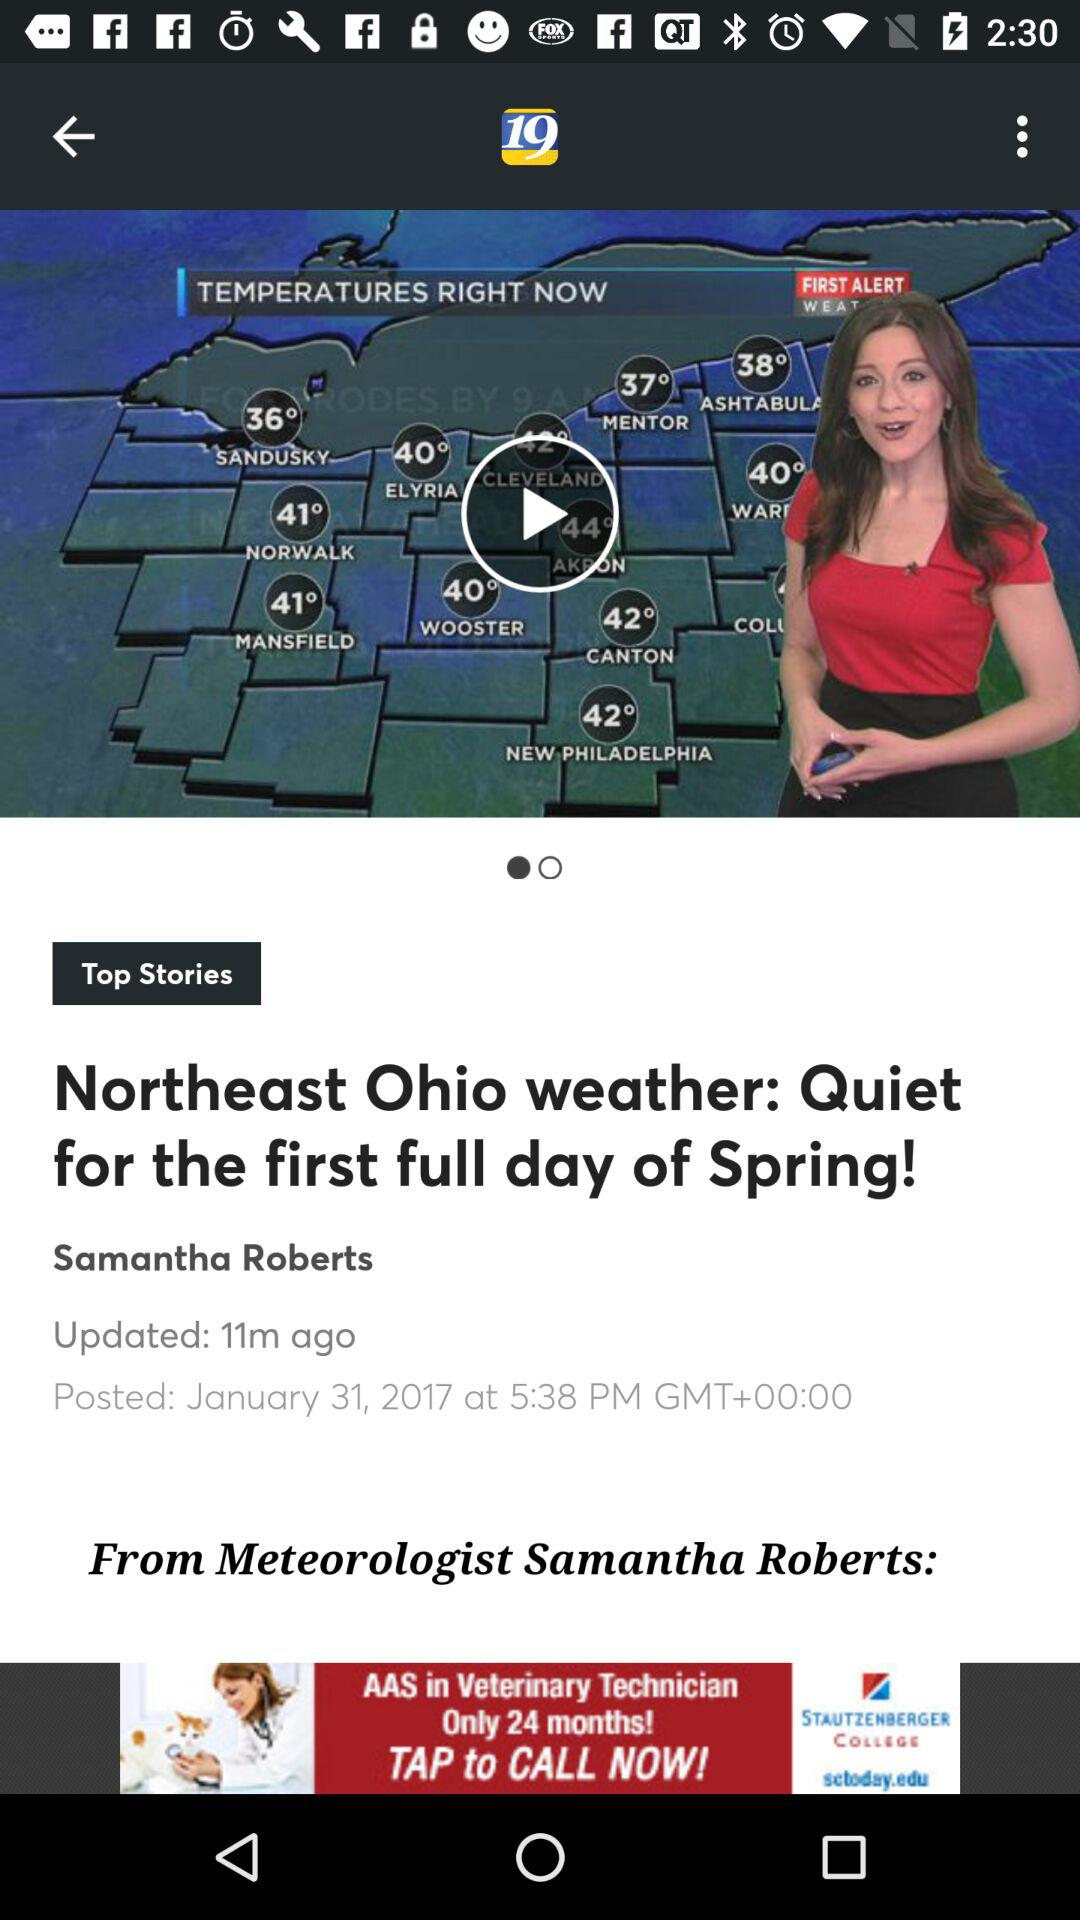How many minutes ago was the Northeast Ohio weather updated? The Northeast Ohio weather was last updated 11 minutes ago. 